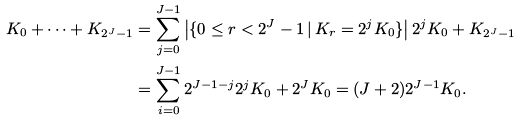Convert formula to latex. <formula><loc_0><loc_0><loc_500><loc_500>K _ { 0 } + \dots + K _ { 2 ^ { J } - 1 } & = \sum _ { j = 0 } ^ { J - 1 } \left | \{ 0 \leq r < 2 ^ { J } - 1 \, | \, K _ { r } = 2 ^ { j } K _ { 0 } \} \right | 2 ^ { j } K _ { 0 } + K _ { 2 ^ { J } - 1 } \\ & = \sum _ { i = 0 } ^ { J - 1 } 2 ^ { J - 1 - j } 2 ^ { j } K _ { 0 } + 2 ^ { J } K _ { 0 } = ( J + 2 ) 2 ^ { J - 1 } K _ { 0 } .</formula> 